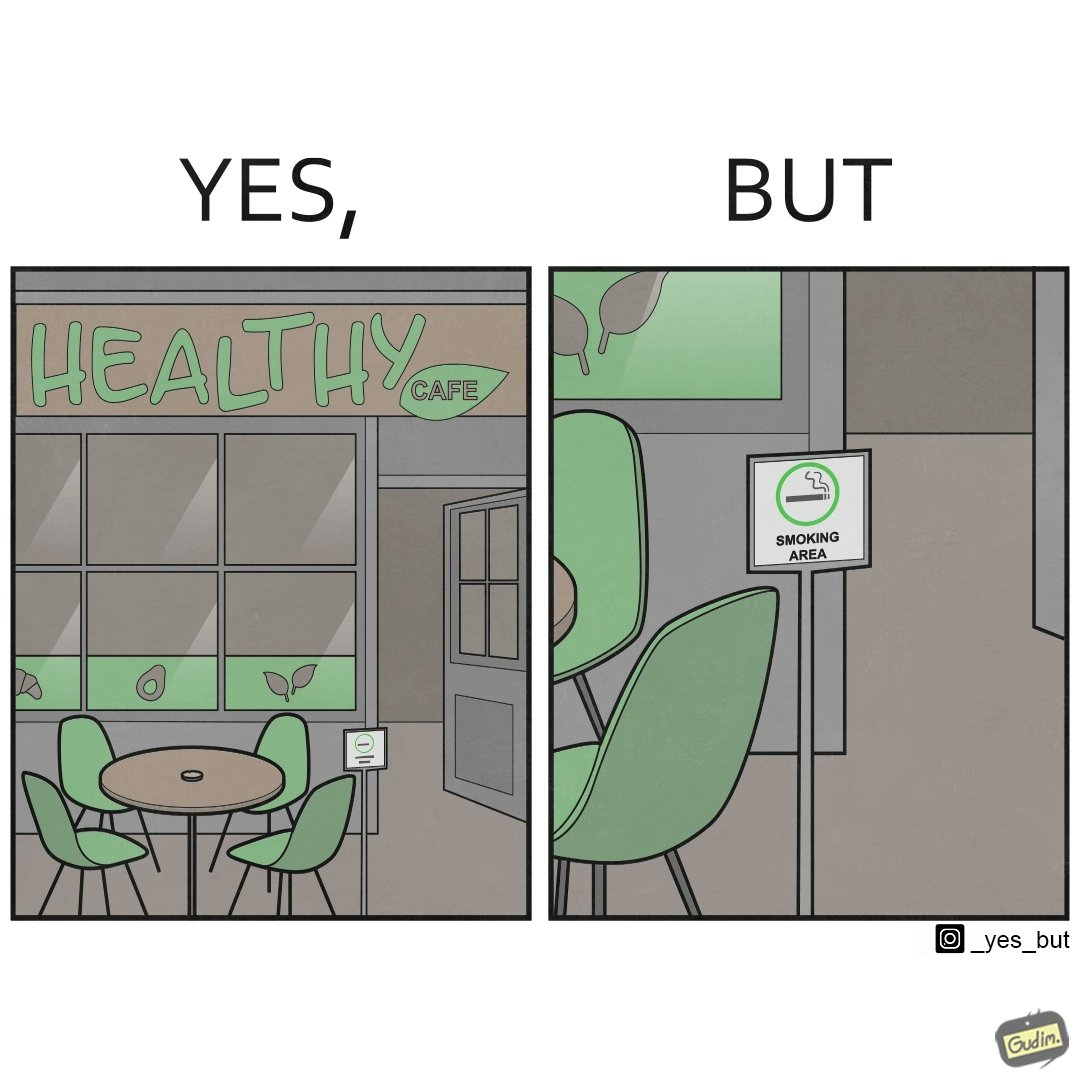Is there satirical content in this image? Yes, this image is satirical. 